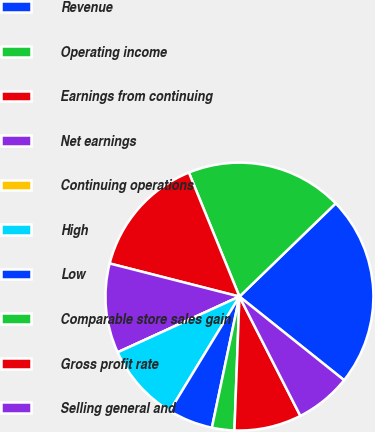Convert chart. <chart><loc_0><loc_0><loc_500><loc_500><pie_chart><fcel>Revenue<fcel>Operating income<fcel>Earnings from continuing<fcel>Net earnings<fcel>Continuing operations<fcel>High<fcel>Low<fcel>Comparable store sales gain<fcel>Gross profit rate<fcel>Selling general and<nl><fcel>22.97%<fcel>18.92%<fcel>14.86%<fcel>10.81%<fcel>0.0%<fcel>9.46%<fcel>5.41%<fcel>2.7%<fcel>8.11%<fcel>6.76%<nl></chart> 